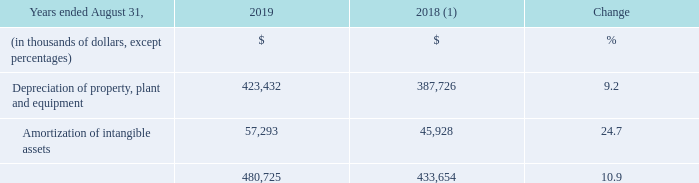3.3 DEPRECIATION AND AMORTIZATION
(1) Fiscal 2018 was restated to comply with IFRS 15 and to reflect a change in accounting policy as well as to reclassify results from Cogeco Peer 1 as discontinued operations. For further details, please consult the "Accounting policies" and "Discontinued operations" sections.
Fiscal 2019 depreciation and amortization expense increased by 10.9% resulting mainly from the impact of the MetroCast acquisition combined with additional depreciation from the acquisitions of property, plant and equipment during the fiscal year and the appreciation of the US dollar against the Canadian dollar compared to the prior year.
What was the increase in the depreciation and amortization expense in 2019? 10.9%. Fiscal 2018 was reinstated to which accounting standard? Ifrs 15. What was the Depreciation of property, plant and equipment in 2019?
Answer scale should be: thousand. 423,432. What was the increase / (decrease) in the Depreciation of property, plant and equipment from 2018 to 2019?
Answer scale should be: thousand. 423,432 - 387,726
Answer: 35706. What was the average Amortization of intangible assets between 2018 and 2019?
Answer scale should be: thousand. (57,293 + 45,928) / 2
Answer: 51610.5. What was the increase / (decrease) in Amortization of intangible assets from 2018 to 2019?
Answer scale should be: thousand. 57,293 - 45,928
Answer: 11365. 